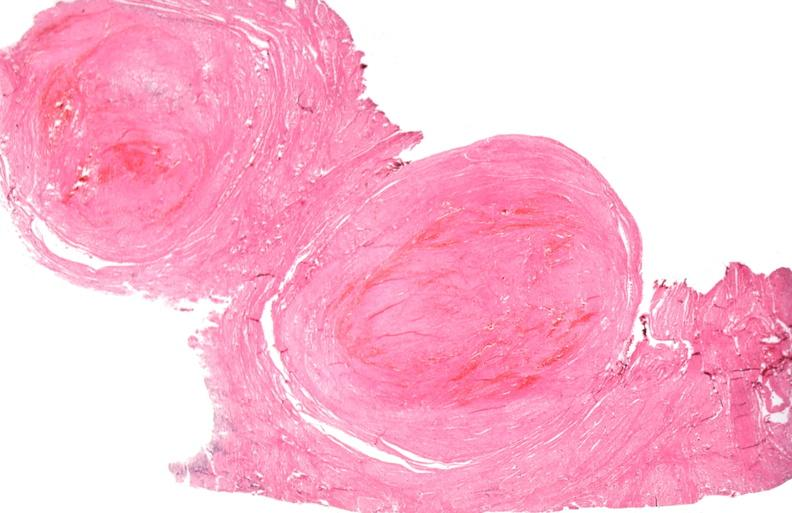does gangrene toe in infant show uterus, leiomyoma?
Answer the question using a single word or phrase. No 